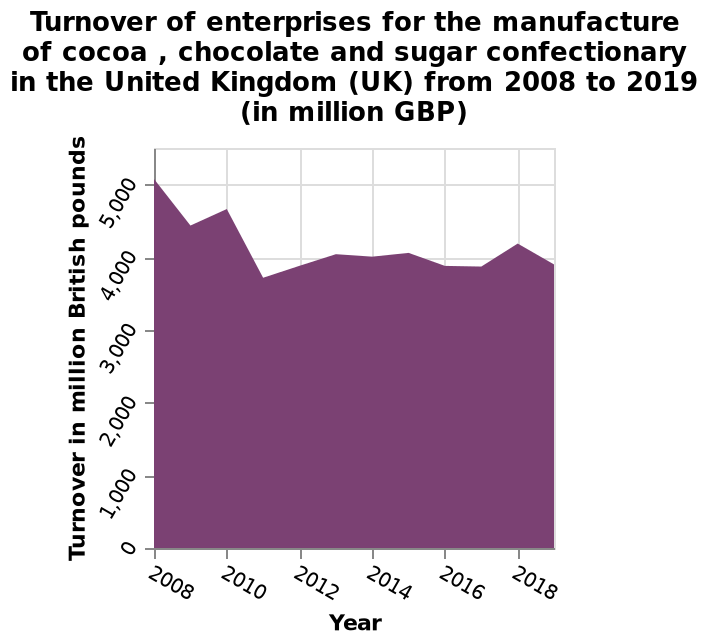<image>
In which year did turnover fall to a low point?   Turnover fell to a low point in 2011. Describe the following image in detail This is a area plot titled Turnover of enterprises for the manufacture of cocoa , chocolate and sugar confectionary in the United Kingdom (UK) from 2008 to 2019 (in million GBP). There is a linear scale of range 0 to 5,000 along the y-axis, labeled Turnover in million British pounds. The x-axis measures Year as a linear scale from 2008 to 2018. What is the x-axis scale on the area plot? The x-axis scale on the area plot measures the year as a linear scale from 2008 to 2018. Does the x-axis scale on the area plot measure the year as a linear scale from 2008 to 2028? No.The x-axis scale on the area plot measures the year as a linear scale from 2008 to 2018. 